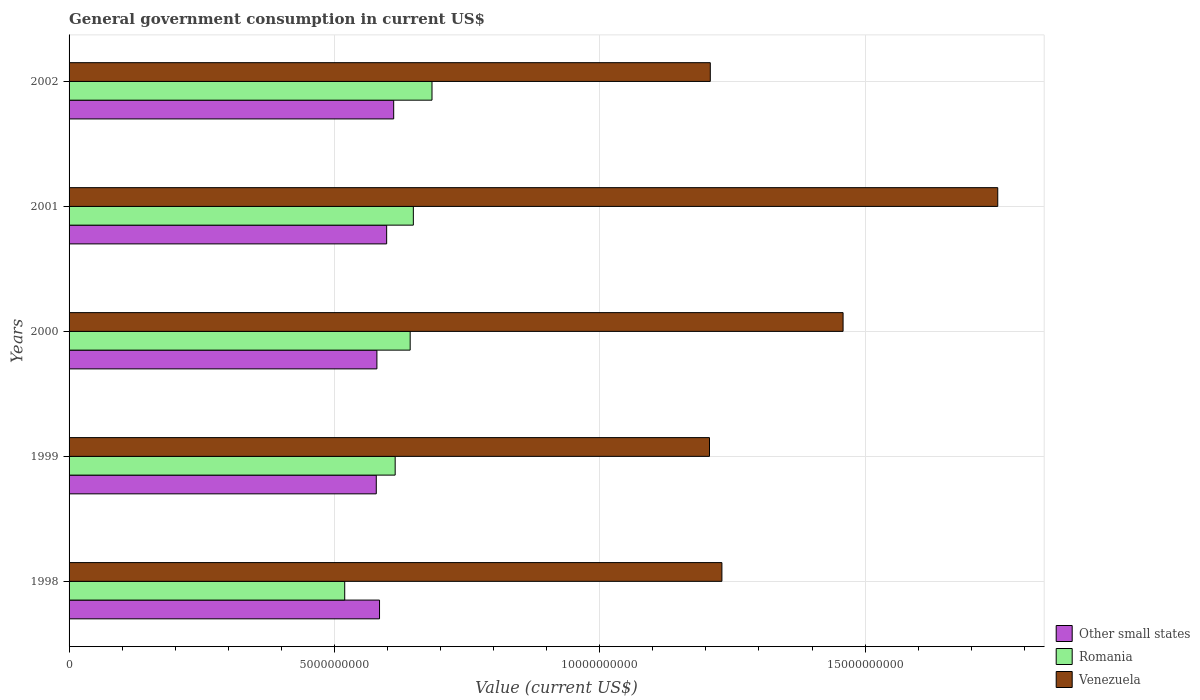How many different coloured bars are there?
Make the answer very short. 3. Are the number of bars per tick equal to the number of legend labels?
Offer a terse response. Yes. Are the number of bars on each tick of the Y-axis equal?
Make the answer very short. Yes. How many bars are there on the 2nd tick from the bottom?
Give a very brief answer. 3. What is the label of the 4th group of bars from the top?
Provide a succinct answer. 1999. In how many cases, is the number of bars for a given year not equal to the number of legend labels?
Offer a terse response. 0. What is the government conusmption in Other small states in 1999?
Offer a terse response. 5.79e+09. Across all years, what is the maximum government conusmption in Other small states?
Give a very brief answer. 6.12e+09. Across all years, what is the minimum government conusmption in Other small states?
Make the answer very short. 5.79e+09. In which year was the government conusmption in Romania maximum?
Ensure brevity in your answer.  2002. What is the total government conusmption in Romania in the graph?
Your response must be concise. 3.11e+1. What is the difference between the government conusmption in Other small states in 1998 and that in 2000?
Offer a terse response. 4.95e+07. What is the difference between the government conusmption in Romania in 2000 and the government conusmption in Venezuela in 1999?
Keep it short and to the point. -5.64e+09. What is the average government conusmption in Other small states per year?
Your response must be concise. 5.91e+09. In the year 1999, what is the difference between the government conusmption in Romania and government conusmption in Other small states?
Your answer should be very brief. 3.56e+08. What is the ratio of the government conusmption in Venezuela in 1998 to that in 2000?
Offer a terse response. 0.84. Is the government conusmption in Venezuela in 1999 less than that in 2002?
Give a very brief answer. Yes. Is the difference between the government conusmption in Romania in 1998 and 1999 greater than the difference between the government conusmption in Other small states in 1998 and 1999?
Provide a succinct answer. No. What is the difference between the highest and the second highest government conusmption in Other small states?
Provide a short and direct response. 1.32e+08. What is the difference between the highest and the lowest government conusmption in Romania?
Your answer should be compact. 1.64e+09. What does the 2nd bar from the top in 1998 represents?
Offer a terse response. Romania. What does the 3rd bar from the bottom in 1998 represents?
Give a very brief answer. Venezuela. How many bars are there?
Provide a succinct answer. 15. Are all the bars in the graph horizontal?
Provide a short and direct response. Yes. How many years are there in the graph?
Provide a short and direct response. 5. Does the graph contain grids?
Ensure brevity in your answer.  Yes. Where does the legend appear in the graph?
Provide a short and direct response. Bottom right. How many legend labels are there?
Your response must be concise. 3. What is the title of the graph?
Offer a very short reply. General government consumption in current US$. What is the label or title of the X-axis?
Your answer should be compact. Value (current US$). What is the Value (current US$) in Other small states in 1998?
Provide a short and direct response. 5.85e+09. What is the Value (current US$) in Romania in 1998?
Your answer should be very brief. 5.19e+09. What is the Value (current US$) of Venezuela in 1998?
Your response must be concise. 1.23e+1. What is the Value (current US$) in Other small states in 1999?
Your answer should be very brief. 5.79e+09. What is the Value (current US$) of Romania in 1999?
Your response must be concise. 6.14e+09. What is the Value (current US$) of Venezuela in 1999?
Provide a succinct answer. 1.21e+1. What is the Value (current US$) in Other small states in 2000?
Your answer should be very brief. 5.80e+09. What is the Value (current US$) in Romania in 2000?
Ensure brevity in your answer.  6.43e+09. What is the Value (current US$) of Venezuela in 2000?
Your answer should be compact. 1.46e+1. What is the Value (current US$) in Other small states in 2001?
Give a very brief answer. 5.98e+09. What is the Value (current US$) in Romania in 2001?
Provide a succinct answer. 6.49e+09. What is the Value (current US$) of Venezuela in 2001?
Provide a succinct answer. 1.75e+1. What is the Value (current US$) of Other small states in 2002?
Provide a succinct answer. 6.12e+09. What is the Value (current US$) in Romania in 2002?
Give a very brief answer. 6.84e+09. What is the Value (current US$) in Venezuela in 2002?
Offer a terse response. 1.21e+1. Across all years, what is the maximum Value (current US$) of Other small states?
Your response must be concise. 6.12e+09. Across all years, what is the maximum Value (current US$) of Romania?
Offer a terse response. 6.84e+09. Across all years, what is the maximum Value (current US$) in Venezuela?
Your response must be concise. 1.75e+1. Across all years, what is the minimum Value (current US$) in Other small states?
Your response must be concise. 5.79e+09. Across all years, what is the minimum Value (current US$) of Romania?
Make the answer very short. 5.19e+09. Across all years, what is the minimum Value (current US$) of Venezuela?
Your answer should be very brief. 1.21e+1. What is the total Value (current US$) in Other small states in the graph?
Your answer should be very brief. 2.95e+1. What is the total Value (current US$) of Romania in the graph?
Offer a very short reply. 3.11e+1. What is the total Value (current US$) in Venezuela in the graph?
Your answer should be very brief. 6.85e+1. What is the difference between the Value (current US$) of Other small states in 1998 and that in 1999?
Provide a short and direct response. 6.12e+07. What is the difference between the Value (current US$) in Romania in 1998 and that in 1999?
Provide a short and direct response. -9.51e+08. What is the difference between the Value (current US$) of Venezuela in 1998 and that in 1999?
Your response must be concise. 2.34e+08. What is the difference between the Value (current US$) of Other small states in 1998 and that in 2000?
Provide a short and direct response. 4.95e+07. What is the difference between the Value (current US$) in Romania in 1998 and that in 2000?
Provide a succinct answer. -1.23e+09. What is the difference between the Value (current US$) of Venezuela in 1998 and that in 2000?
Your response must be concise. -2.28e+09. What is the difference between the Value (current US$) in Other small states in 1998 and that in 2001?
Offer a terse response. -1.34e+08. What is the difference between the Value (current US$) of Romania in 1998 and that in 2001?
Your answer should be compact. -1.29e+09. What is the difference between the Value (current US$) of Venezuela in 1998 and that in 2001?
Your answer should be compact. -5.20e+09. What is the difference between the Value (current US$) of Other small states in 1998 and that in 2002?
Provide a succinct answer. -2.67e+08. What is the difference between the Value (current US$) of Romania in 1998 and that in 2002?
Give a very brief answer. -1.64e+09. What is the difference between the Value (current US$) in Venezuela in 1998 and that in 2002?
Ensure brevity in your answer.  2.19e+08. What is the difference between the Value (current US$) of Other small states in 1999 and that in 2000?
Your answer should be very brief. -1.17e+07. What is the difference between the Value (current US$) in Romania in 1999 and that in 2000?
Offer a very short reply. -2.83e+08. What is the difference between the Value (current US$) in Venezuela in 1999 and that in 2000?
Make the answer very short. -2.52e+09. What is the difference between the Value (current US$) of Other small states in 1999 and that in 2001?
Provide a short and direct response. -1.95e+08. What is the difference between the Value (current US$) of Romania in 1999 and that in 2001?
Your answer should be very brief. -3.43e+08. What is the difference between the Value (current US$) of Venezuela in 1999 and that in 2001?
Your response must be concise. -5.43e+09. What is the difference between the Value (current US$) in Other small states in 1999 and that in 2002?
Provide a short and direct response. -3.28e+08. What is the difference between the Value (current US$) of Romania in 1999 and that in 2002?
Offer a terse response. -6.94e+08. What is the difference between the Value (current US$) of Venezuela in 1999 and that in 2002?
Provide a short and direct response. -1.50e+07. What is the difference between the Value (current US$) of Other small states in 2000 and that in 2001?
Provide a short and direct response. -1.84e+08. What is the difference between the Value (current US$) in Romania in 2000 and that in 2001?
Offer a very short reply. -5.99e+07. What is the difference between the Value (current US$) in Venezuela in 2000 and that in 2001?
Your answer should be very brief. -2.91e+09. What is the difference between the Value (current US$) of Other small states in 2000 and that in 2002?
Your answer should be very brief. -3.16e+08. What is the difference between the Value (current US$) of Romania in 2000 and that in 2002?
Your answer should be very brief. -4.11e+08. What is the difference between the Value (current US$) in Venezuela in 2000 and that in 2002?
Your response must be concise. 2.50e+09. What is the difference between the Value (current US$) in Other small states in 2001 and that in 2002?
Make the answer very short. -1.32e+08. What is the difference between the Value (current US$) of Romania in 2001 and that in 2002?
Offer a terse response. -3.51e+08. What is the difference between the Value (current US$) of Venezuela in 2001 and that in 2002?
Your answer should be compact. 5.42e+09. What is the difference between the Value (current US$) of Other small states in 1998 and the Value (current US$) of Romania in 1999?
Your response must be concise. -2.95e+08. What is the difference between the Value (current US$) of Other small states in 1998 and the Value (current US$) of Venezuela in 1999?
Your answer should be very brief. -6.22e+09. What is the difference between the Value (current US$) in Romania in 1998 and the Value (current US$) in Venezuela in 1999?
Give a very brief answer. -6.87e+09. What is the difference between the Value (current US$) in Other small states in 1998 and the Value (current US$) in Romania in 2000?
Give a very brief answer. -5.77e+08. What is the difference between the Value (current US$) of Other small states in 1998 and the Value (current US$) of Venezuela in 2000?
Provide a short and direct response. -8.73e+09. What is the difference between the Value (current US$) of Romania in 1998 and the Value (current US$) of Venezuela in 2000?
Ensure brevity in your answer.  -9.39e+09. What is the difference between the Value (current US$) of Other small states in 1998 and the Value (current US$) of Romania in 2001?
Offer a terse response. -6.37e+08. What is the difference between the Value (current US$) in Other small states in 1998 and the Value (current US$) in Venezuela in 2001?
Ensure brevity in your answer.  -1.16e+1. What is the difference between the Value (current US$) of Romania in 1998 and the Value (current US$) of Venezuela in 2001?
Your answer should be compact. -1.23e+1. What is the difference between the Value (current US$) in Other small states in 1998 and the Value (current US$) in Romania in 2002?
Provide a short and direct response. -9.88e+08. What is the difference between the Value (current US$) in Other small states in 1998 and the Value (current US$) in Venezuela in 2002?
Make the answer very short. -6.23e+09. What is the difference between the Value (current US$) in Romania in 1998 and the Value (current US$) in Venezuela in 2002?
Keep it short and to the point. -6.89e+09. What is the difference between the Value (current US$) of Other small states in 1999 and the Value (current US$) of Romania in 2000?
Keep it short and to the point. -6.38e+08. What is the difference between the Value (current US$) in Other small states in 1999 and the Value (current US$) in Venezuela in 2000?
Make the answer very short. -8.80e+09. What is the difference between the Value (current US$) of Romania in 1999 and the Value (current US$) of Venezuela in 2000?
Ensure brevity in your answer.  -8.44e+09. What is the difference between the Value (current US$) of Other small states in 1999 and the Value (current US$) of Romania in 2001?
Offer a very short reply. -6.98e+08. What is the difference between the Value (current US$) of Other small states in 1999 and the Value (current US$) of Venezuela in 2001?
Your response must be concise. -1.17e+1. What is the difference between the Value (current US$) of Romania in 1999 and the Value (current US$) of Venezuela in 2001?
Your response must be concise. -1.14e+1. What is the difference between the Value (current US$) of Other small states in 1999 and the Value (current US$) of Romania in 2002?
Offer a very short reply. -1.05e+09. What is the difference between the Value (current US$) in Other small states in 1999 and the Value (current US$) in Venezuela in 2002?
Keep it short and to the point. -6.29e+09. What is the difference between the Value (current US$) in Romania in 1999 and the Value (current US$) in Venezuela in 2002?
Give a very brief answer. -5.94e+09. What is the difference between the Value (current US$) of Other small states in 2000 and the Value (current US$) of Romania in 2001?
Provide a succinct answer. -6.87e+08. What is the difference between the Value (current US$) of Other small states in 2000 and the Value (current US$) of Venezuela in 2001?
Offer a terse response. -1.17e+1. What is the difference between the Value (current US$) in Romania in 2000 and the Value (current US$) in Venezuela in 2001?
Make the answer very short. -1.11e+1. What is the difference between the Value (current US$) of Other small states in 2000 and the Value (current US$) of Romania in 2002?
Make the answer very short. -1.04e+09. What is the difference between the Value (current US$) in Other small states in 2000 and the Value (current US$) in Venezuela in 2002?
Your answer should be compact. -6.28e+09. What is the difference between the Value (current US$) of Romania in 2000 and the Value (current US$) of Venezuela in 2002?
Offer a very short reply. -5.66e+09. What is the difference between the Value (current US$) in Other small states in 2001 and the Value (current US$) in Romania in 2002?
Your answer should be very brief. -8.54e+08. What is the difference between the Value (current US$) of Other small states in 2001 and the Value (current US$) of Venezuela in 2002?
Offer a very short reply. -6.10e+09. What is the difference between the Value (current US$) of Romania in 2001 and the Value (current US$) of Venezuela in 2002?
Ensure brevity in your answer.  -5.60e+09. What is the average Value (current US$) in Other small states per year?
Ensure brevity in your answer.  5.91e+09. What is the average Value (current US$) in Romania per year?
Offer a very short reply. 6.22e+09. What is the average Value (current US$) of Venezuela per year?
Offer a very short reply. 1.37e+1. In the year 1998, what is the difference between the Value (current US$) of Other small states and Value (current US$) of Romania?
Your response must be concise. 6.56e+08. In the year 1998, what is the difference between the Value (current US$) in Other small states and Value (current US$) in Venezuela?
Offer a terse response. -6.45e+09. In the year 1998, what is the difference between the Value (current US$) of Romania and Value (current US$) of Venezuela?
Provide a short and direct response. -7.11e+09. In the year 1999, what is the difference between the Value (current US$) in Other small states and Value (current US$) in Romania?
Offer a very short reply. -3.56e+08. In the year 1999, what is the difference between the Value (current US$) of Other small states and Value (current US$) of Venezuela?
Your answer should be very brief. -6.28e+09. In the year 1999, what is the difference between the Value (current US$) of Romania and Value (current US$) of Venezuela?
Provide a succinct answer. -5.92e+09. In the year 2000, what is the difference between the Value (current US$) in Other small states and Value (current US$) in Romania?
Your answer should be compact. -6.27e+08. In the year 2000, what is the difference between the Value (current US$) in Other small states and Value (current US$) in Venezuela?
Ensure brevity in your answer.  -8.78e+09. In the year 2000, what is the difference between the Value (current US$) of Romania and Value (current US$) of Venezuela?
Ensure brevity in your answer.  -8.16e+09. In the year 2001, what is the difference between the Value (current US$) in Other small states and Value (current US$) in Romania?
Provide a short and direct response. -5.03e+08. In the year 2001, what is the difference between the Value (current US$) in Other small states and Value (current US$) in Venezuela?
Give a very brief answer. -1.15e+1. In the year 2001, what is the difference between the Value (current US$) of Romania and Value (current US$) of Venezuela?
Provide a succinct answer. -1.10e+1. In the year 2002, what is the difference between the Value (current US$) of Other small states and Value (current US$) of Romania?
Keep it short and to the point. -7.22e+08. In the year 2002, what is the difference between the Value (current US$) in Other small states and Value (current US$) in Venezuela?
Make the answer very short. -5.97e+09. In the year 2002, what is the difference between the Value (current US$) in Romania and Value (current US$) in Venezuela?
Your response must be concise. -5.24e+09. What is the ratio of the Value (current US$) in Other small states in 1998 to that in 1999?
Make the answer very short. 1.01. What is the ratio of the Value (current US$) in Romania in 1998 to that in 1999?
Make the answer very short. 0.85. What is the ratio of the Value (current US$) in Venezuela in 1998 to that in 1999?
Provide a succinct answer. 1.02. What is the ratio of the Value (current US$) in Other small states in 1998 to that in 2000?
Ensure brevity in your answer.  1.01. What is the ratio of the Value (current US$) in Romania in 1998 to that in 2000?
Offer a very short reply. 0.81. What is the ratio of the Value (current US$) of Venezuela in 1998 to that in 2000?
Your answer should be very brief. 0.84. What is the ratio of the Value (current US$) of Other small states in 1998 to that in 2001?
Your response must be concise. 0.98. What is the ratio of the Value (current US$) in Romania in 1998 to that in 2001?
Give a very brief answer. 0.8. What is the ratio of the Value (current US$) in Venezuela in 1998 to that in 2001?
Offer a terse response. 0.7. What is the ratio of the Value (current US$) of Other small states in 1998 to that in 2002?
Your answer should be very brief. 0.96. What is the ratio of the Value (current US$) of Romania in 1998 to that in 2002?
Your response must be concise. 0.76. What is the ratio of the Value (current US$) in Venezuela in 1998 to that in 2002?
Offer a terse response. 1.02. What is the ratio of the Value (current US$) of Romania in 1999 to that in 2000?
Make the answer very short. 0.96. What is the ratio of the Value (current US$) of Venezuela in 1999 to that in 2000?
Offer a terse response. 0.83. What is the ratio of the Value (current US$) in Other small states in 1999 to that in 2001?
Make the answer very short. 0.97. What is the ratio of the Value (current US$) in Romania in 1999 to that in 2001?
Make the answer very short. 0.95. What is the ratio of the Value (current US$) in Venezuela in 1999 to that in 2001?
Offer a very short reply. 0.69. What is the ratio of the Value (current US$) of Other small states in 1999 to that in 2002?
Provide a short and direct response. 0.95. What is the ratio of the Value (current US$) in Romania in 1999 to that in 2002?
Your answer should be compact. 0.9. What is the ratio of the Value (current US$) in Other small states in 2000 to that in 2001?
Provide a short and direct response. 0.97. What is the ratio of the Value (current US$) in Venezuela in 2000 to that in 2001?
Keep it short and to the point. 0.83. What is the ratio of the Value (current US$) of Other small states in 2000 to that in 2002?
Keep it short and to the point. 0.95. What is the ratio of the Value (current US$) in Romania in 2000 to that in 2002?
Keep it short and to the point. 0.94. What is the ratio of the Value (current US$) in Venezuela in 2000 to that in 2002?
Give a very brief answer. 1.21. What is the ratio of the Value (current US$) in Other small states in 2001 to that in 2002?
Make the answer very short. 0.98. What is the ratio of the Value (current US$) of Romania in 2001 to that in 2002?
Your answer should be compact. 0.95. What is the ratio of the Value (current US$) of Venezuela in 2001 to that in 2002?
Offer a terse response. 1.45. What is the difference between the highest and the second highest Value (current US$) of Other small states?
Provide a short and direct response. 1.32e+08. What is the difference between the highest and the second highest Value (current US$) in Romania?
Provide a succinct answer. 3.51e+08. What is the difference between the highest and the second highest Value (current US$) in Venezuela?
Your answer should be very brief. 2.91e+09. What is the difference between the highest and the lowest Value (current US$) of Other small states?
Provide a short and direct response. 3.28e+08. What is the difference between the highest and the lowest Value (current US$) in Romania?
Provide a short and direct response. 1.64e+09. What is the difference between the highest and the lowest Value (current US$) of Venezuela?
Offer a very short reply. 5.43e+09. 